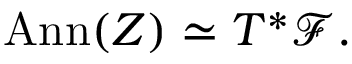Convert formula to latex. <formula><loc_0><loc_0><loc_500><loc_500>A n n ( Z ) \simeq T ^ { * } { \mathcal { F } } .</formula> 